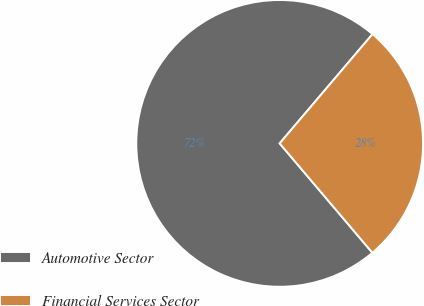<chart> <loc_0><loc_0><loc_500><loc_500><pie_chart><fcel>Automotive Sector<fcel>Financial Services Sector<nl><fcel>72.4%<fcel>27.6%<nl></chart> 